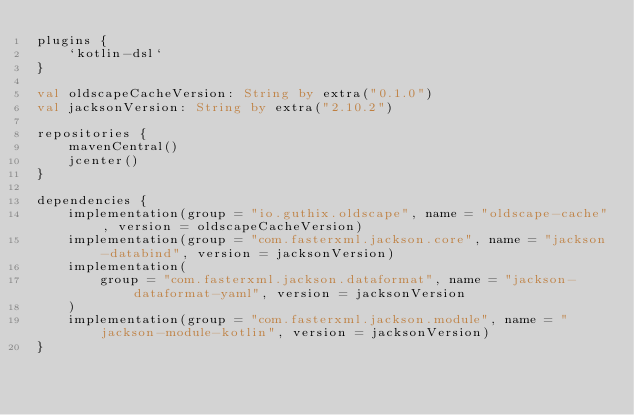Convert code to text. <code><loc_0><loc_0><loc_500><loc_500><_Kotlin_>plugins {
    `kotlin-dsl`
}

val oldscapeCacheVersion: String by extra("0.1.0")
val jacksonVersion: String by extra("2.10.2")

repositories {
    mavenCentral()
    jcenter()
}

dependencies {
    implementation(group = "io.guthix.oldscape", name = "oldscape-cache", version = oldscapeCacheVersion)
    implementation(group = "com.fasterxml.jackson.core", name = "jackson-databind", version = jacksonVersion)
    implementation(
        group = "com.fasterxml.jackson.dataformat", name = "jackson-dataformat-yaml", version = jacksonVersion
    )
    implementation(group = "com.fasterxml.jackson.module", name = "jackson-module-kotlin", version = jacksonVersion)
}</code> 